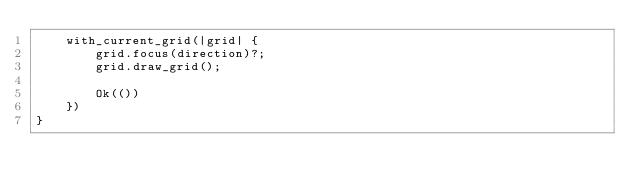Convert code to text. <code><loc_0><loc_0><loc_500><loc_500><_Rust_>    with_current_grid(|grid| {
        grid.focus(direction)?;
        grid.draw_grid();

        Ok(())
    })
}
</code> 